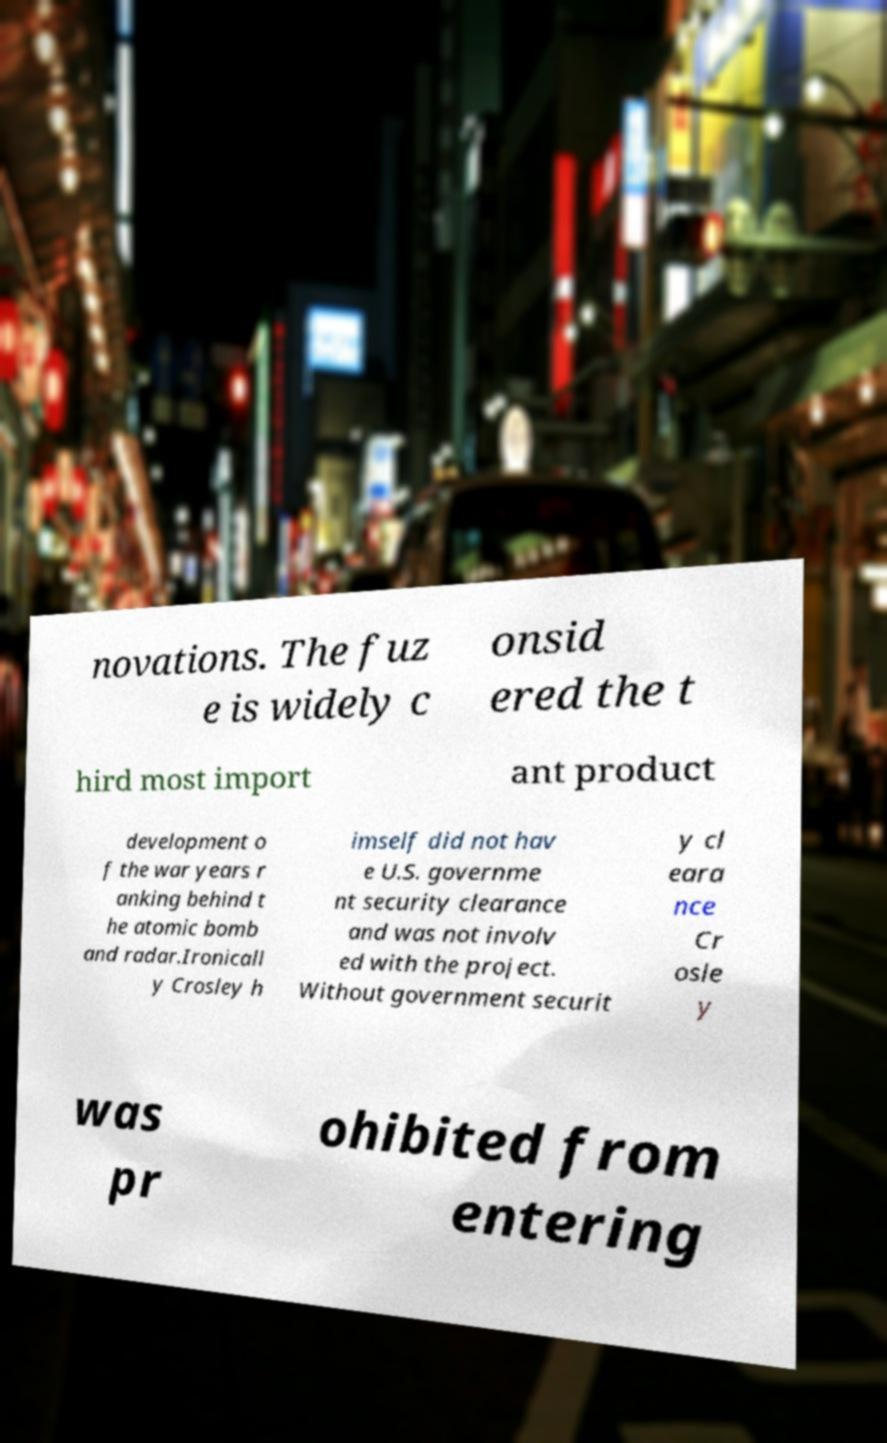Could you extract and type out the text from this image? novations. The fuz e is widely c onsid ered the t hird most import ant product development o f the war years r anking behind t he atomic bomb and radar.Ironicall y Crosley h imself did not hav e U.S. governme nt security clearance and was not involv ed with the project. Without government securit y cl eara nce Cr osle y was pr ohibited from entering 